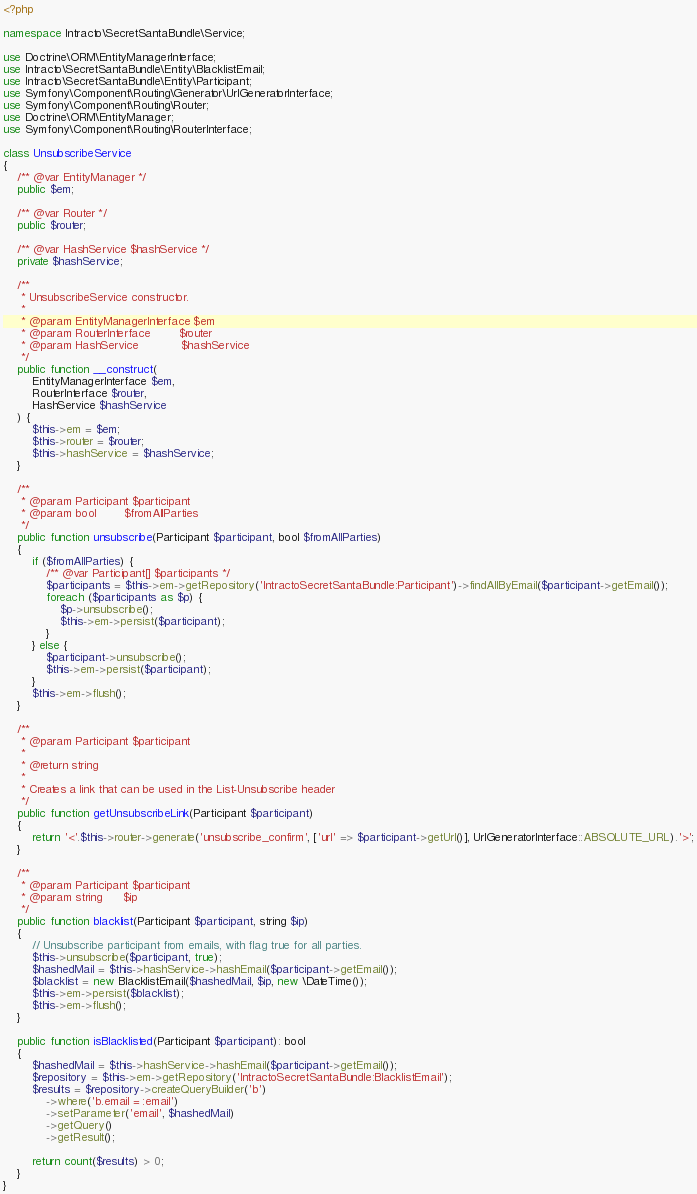<code> <loc_0><loc_0><loc_500><loc_500><_PHP_><?php

namespace Intracto\SecretSantaBundle\Service;

use Doctrine\ORM\EntityManagerInterface;
use Intracto\SecretSantaBundle\Entity\BlacklistEmail;
use Intracto\SecretSantaBundle\Entity\Participant;
use Symfony\Component\Routing\Generator\UrlGeneratorInterface;
use Symfony\Component\Routing\Router;
use Doctrine\ORM\EntityManager;
use Symfony\Component\Routing\RouterInterface;

class UnsubscribeService
{
    /** @var EntityManager */
    public $em;

    /** @var Router */
    public $router;

    /** @var HashService $hashService */
    private $hashService;

    /**
     * UnsubscribeService constructor.
     *
     * @param EntityManagerInterface $em
     * @param RouterInterface        $router
     * @param HashService            $hashService
     */
    public function __construct(
        EntityManagerInterface $em,
        RouterInterface $router,
        HashService $hashService
    ) {
        $this->em = $em;
        $this->router = $router;
        $this->hashService = $hashService;
    }

    /**
     * @param Participant $participant
     * @param bool        $fromAllParties
     */
    public function unsubscribe(Participant $participant, bool $fromAllParties)
    {
        if ($fromAllParties) {
            /** @var Participant[] $participants */
            $participants = $this->em->getRepository('IntractoSecretSantaBundle:Participant')->findAllByEmail($participant->getEmail());
            foreach ($participants as $p) {
                $p->unsubscribe();
                $this->em->persist($participant);
            }
        } else {
            $participant->unsubscribe();
            $this->em->persist($participant);
        }
        $this->em->flush();
    }

    /**
     * @param Participant $participant
     *
     * @return string
     *
     * Creates a link that can be used in the List-Unsubscribe header
     */
    public function getUnsubscribeLink(Participant $participant)
    {
        return '<'.$this->router->generate('unsubscribe_confirm', ['url' => $participant->getUrl()], UrlGeneratorInterface::ABSOLUTE_URL).'>';
    }

    /**
     * @param Participant $participant
     * @param string      $ip
     */
    public function blacklist(Participant $participant, string $ip)
    {
        // Unsubscribe participant from emails, with flag true for all parties.
        $this->unsubscribe($participant, true);
        $hashedMail = $this->hashService->hashEmail($participant->getEmail());
        $blacklist = new BlacklistEmail($hashedMail, $ip, new \DateTime());
        $this->em->persist($blacklist);
        $this->em->flush();
    }

    public function isBlacklisted(Participant $participant): bool
    {
        $hashedMail = $this->hashService->hashEmail($participant->getEmail());
        $repository = $this->em->getRepository('IntractoSecretSantaBundle:BlacklistEmail');
        $results = $repository->createQueryBuilder('b')
            ->where('b.email = :email')
            ->setParameter('email', $hashedMail)
            ->getQuery()
            ->getResult();

        return count($results) > 0;
    }
}
</code> 